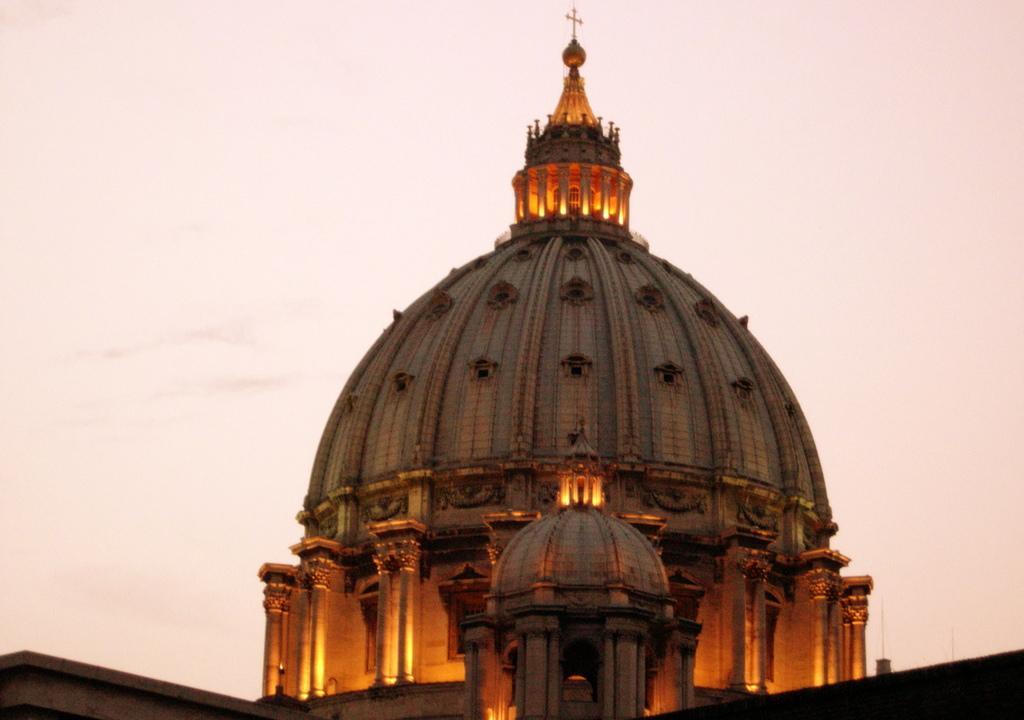In one or two sentences, can you explain what this image depicts? In this image we can see a church, on top of it there is cross symbol, we can also see some lights, and the sky. 